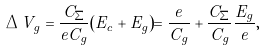<formula> <loc_0><loc_0><loc_500><loc_500>\Delta V _ { g } = \frac { C _ { \Sigma } } { e C _ { g } } ( E _ { c } + E _ { g } ) = \frac { e } { C _ { g } } + \frac { C _ { \Sigma } } { C _ { g } } \frac { E _ { g } } { e } ,</formula> 